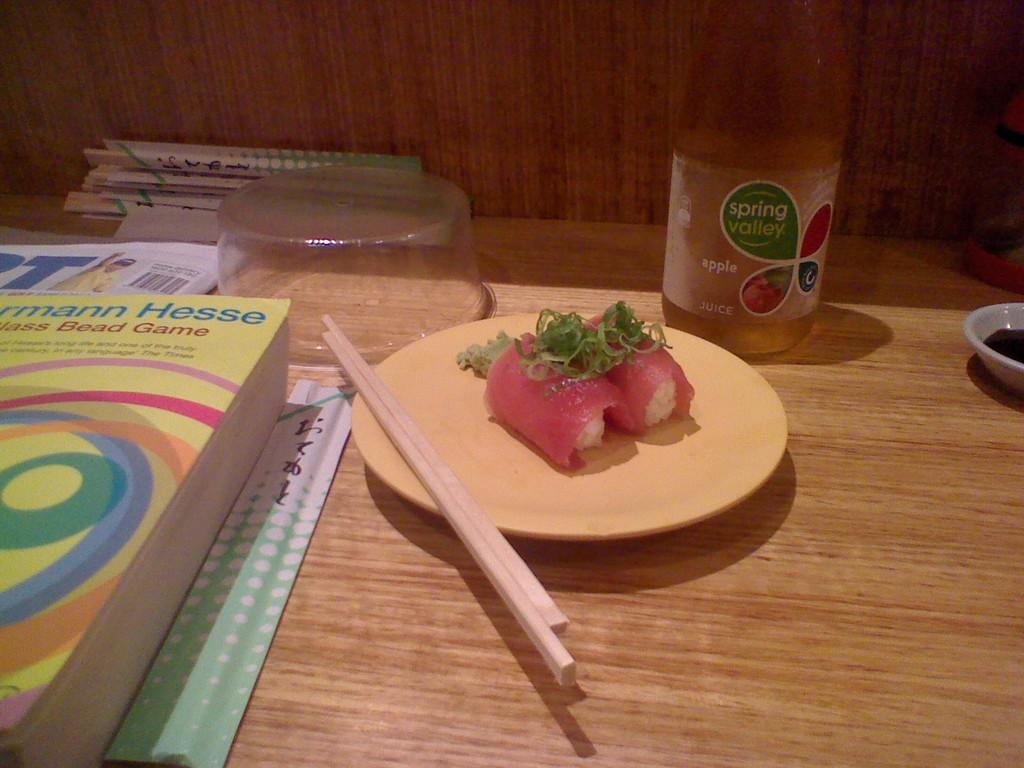Where does the apple juice come from?
Offer a very short reply. Spring valley. What kind of game is it?
Ensure brevity in your answer.  Bead. 